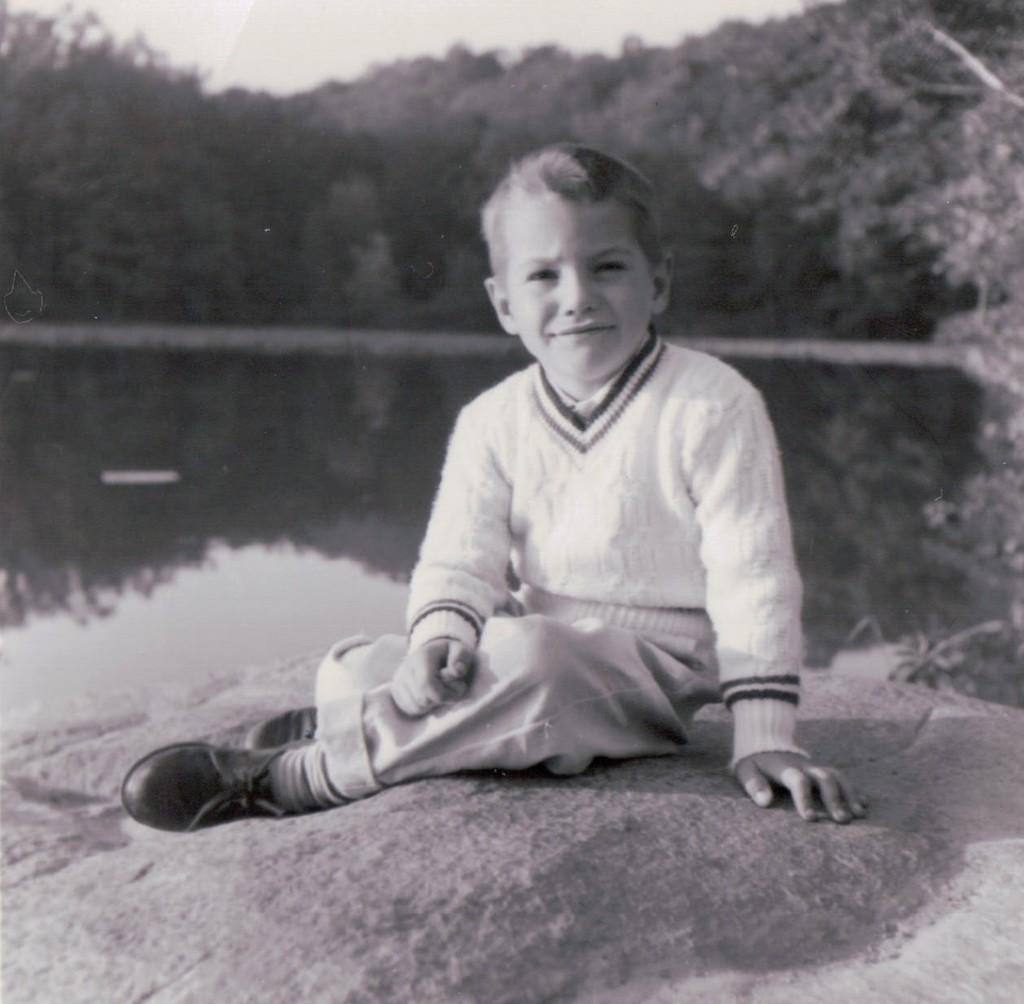Who is the main subject in the image? There is a child in the image. What is the child doing in the image? The child is sitting on a rock. What can be seen in the background of the image? There are trees in the background of the image. What is visible at the bottom of the image? There is water visible at the bottom of the image. What type of religious test is the child taking in the image? There is no religious test present in the image; it simply shows a child sitting on a rock with trees in the background and water at the bottom. How many cherries can be seen in the image? There are no cherries present in the image. 